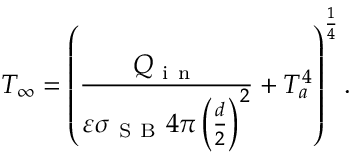Convert formula to latex. <formula><loc_0><loc_0><loc_500><loc_500>T _ { \infty } = \left ( \frac { Q _ { i n } } { \varepsilon \sigma _ { S B } 4 \pi \left ( \frac { d } { 2 } \right ) ^ { 2 } } + T _ { a } ^ { 4 } \right ) ^ { \frac { 1 } { 4 } } .</formula> 